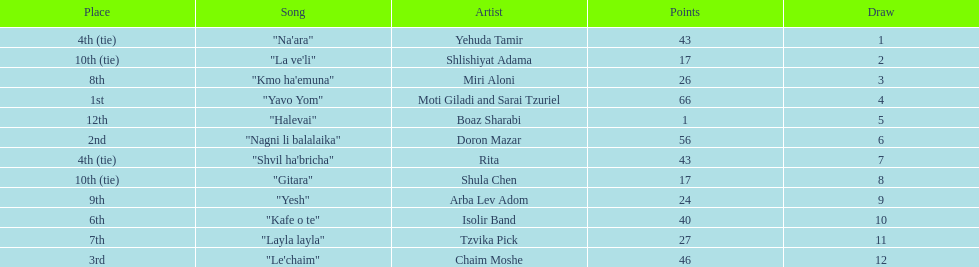Did the song "gitara" or "yesh" earn more points? "Yesh". 